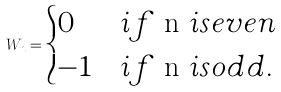<formula> <loc_0><loc_0><loc_500><loc_500>W _ { n } = \begin{cases} 0 & i f $ n $ i s e v e n \\ - 1 & i f $ n $ i s o d d . \end{cases}</formula> 